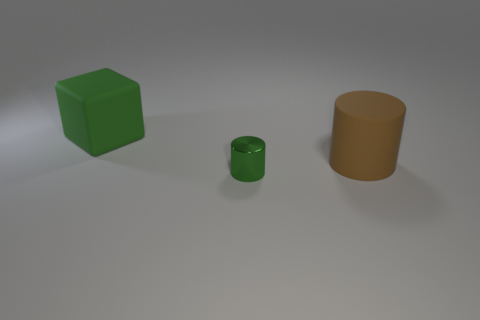Is the number of green metallic cylinders that are to the right of the metallic cylinder the same as the number of tiny green objects that are right of the brown object?
Offer a very short reply. Yes. Do the large matte object to the left of the tiny green object and the brown thing have the same shape?
Your answer should be compact. No. Is there any other thing that has the same material as the large green object?
Ensure brevity in your answer.  Yes. There is a brown matte cylinder; is it the same size as the rubber object to the left of the small green shiny thing?
Ensure brevity in your answer.  Yes. How many other objects are the same color as the metallic object?
Your answer should be very brief. 1. There is a tiny green metal thing; are there any shiny objects in front of it?
Provide a succinct answer. No. How many things are cylinders or things in front of the big green block?
Offer a terse response. 2. Is there a large matte thing behind the green thing left of the small shiny object?
Ensure brevity in your answer.  No. The large matte object that is in front of the rubber object behind the rubber thing right of the green metal thing is what shape?
Make the answer very short. Cylinder. What is the color of the thing that is behind the small metal object and to the left of the brown cylinder?
Give a very brief answer. Green. 